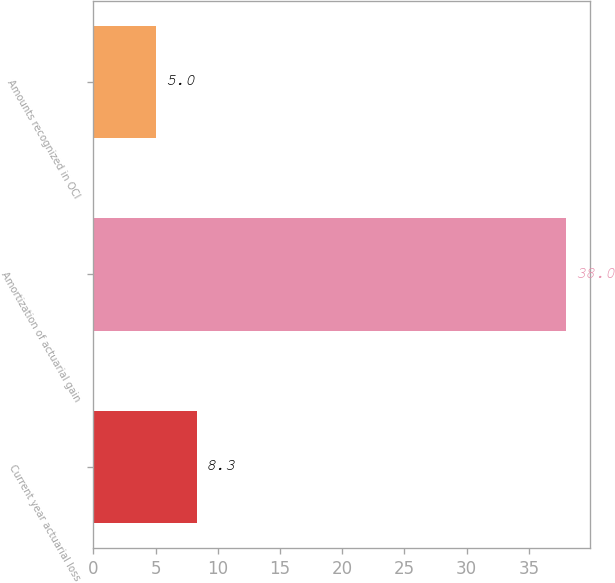Convert chart. <chart><loc_0><loc_0><loc_500><loc_500><bar_chart><fcel>Current year actuarial loss<fcel>Amortization of actuarial gain<fcel>Amounts recognized in OCI<nl><fcel>8.3<fcel>38<fcel>5<nl></chart> 